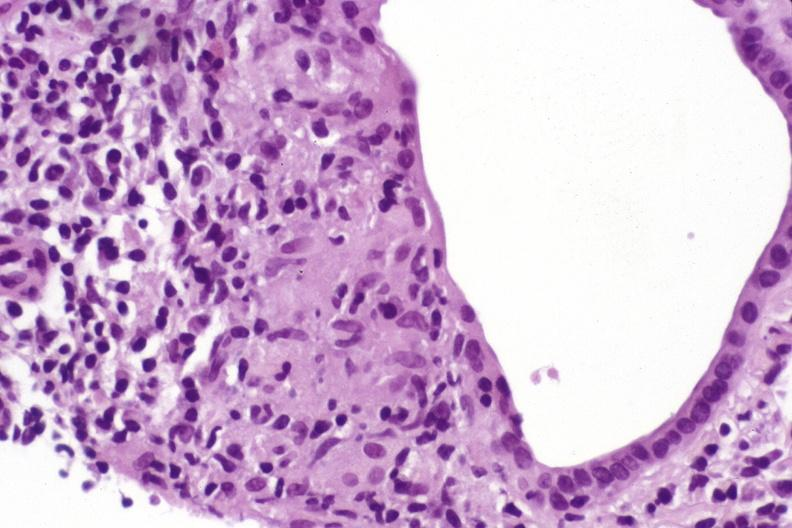s metastatic colon carcinoma present?
Answer the question using a single word or phrase. No 